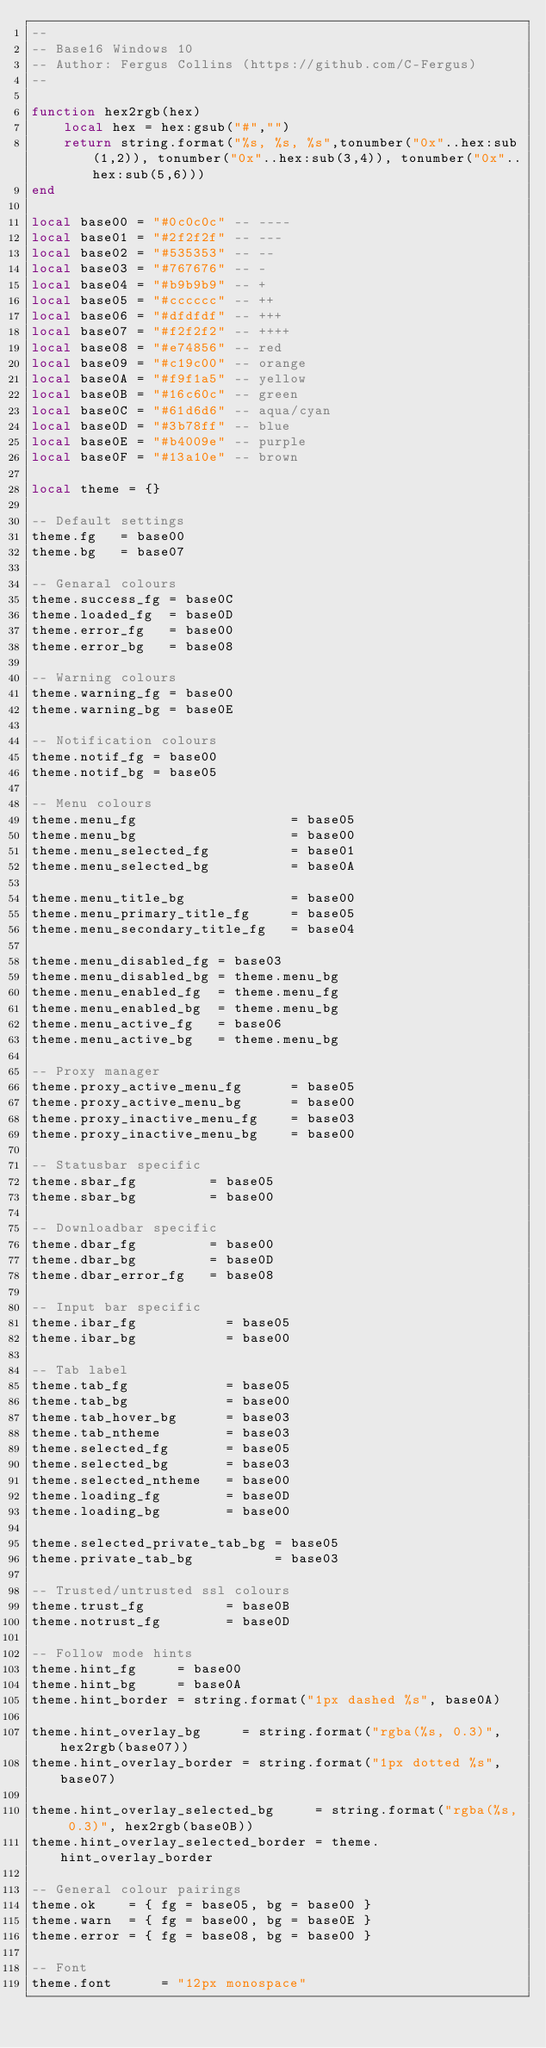<code> <loc_0><loc_0><loc_500><loc_500><_Lua_>--
-- Base16 Windows 10
-- Author: Fergus Collins (https://github.com/C-Fergus)
--

function hex2rgb(hex)
    local hex = hex:gsub("#","")
    return string.format("%s, %s, %s",tonumber("0x"..hex:sub(1,2)), tonumber("0x"..hex:sub(3,4)), tonumber("0x"..hex:sub(5,6)))
end

local base00 = "#0c0c0c" -- ----
local base01 = "#2f2f2f" -- ---
local base02 = "#535353" -- --
local base03 = "#767676" -- -
local base04 = "#b9b9b9" -- +
local base05 = "#cccccc" -- ++
local base06 = "#dfdfdf" -- +++
local base07 = "#f2f2f2" -- ++++
local base08 = "#e74856" -- red
local base09 = "#c19c00" -- orange
local base0A = "#f9f1a5" -- yellow
local base0B = "#16c60c" -- green
local base0C = "#61d6d6" -- aqua/cyan
local base0D = "#3b78ff" -- blue
local base0E = "#b4009e" -- purple
local base0F = "#13a10e" -- brown

local theme = {}

-- Default settings
theme.fg   = base00
theme.bg   = base07

-- Genaral colours
theme.success_fg = base0C
theme.loaded_fg  = base0D
theme.error_fg   = base00
theme.error_bg   = base08

-- Warning colours
theme.warning_fg = base00
theme.warning_bg = base0E

-- Notification colours
theme.notif_fg = base00
theme.notif_bg = base05

-- Menu colours
theme.menu_fg                   = base05
theme.menu_bg                   = base00
theme.menu_selected_fg          = base01
theme.menu_selected_bg          = base0A

theme.menu_title_bg             = base00
theme.menu_primary_title_fg     = base05
theme.menu_secondary_title_fg   = base04

theme.menu_disabled_fg = base03
theme.menu_disabled_bg = theme.menu_bg
theme.menu_enabled_fg  = theme.menu_fg
theme.menu_enabled_bg  = theme.menu_bg
theme.menu_active_fg   = base06
theme.menu_active_bg   = theme.menu_bg

-- Proxy manager
theme.proxy_active_menu_fg      = base05
theme.proxy_active_menu_bg      = base00
theme.proxy_inactive_menu_fg    = base03
theme.proxy_inactive_menu_bg    = base00

-- Statusbar specific
theme.sbar_fg         = base05
theme.sbar_bg         = base00

-- Downloadbar specific
theme.dbar_fg         = base00
theme.dbar_bg         = base0D
theme.dbar_error_fg   = base08

-- Input bar specific
theme.ibar_fg           = base05
theme.ibar_bg           = base00

-- Tab label
theme.tab_fg            = base05
theme.tab_bg            = base00
theme.tab_hover_bg      = base03
theme.tab_ntheme        = base03
theme.selected_fg       = base05
theme.selected_bg       = base03
theme.selected_ntheme   = base00
theme.loading_fg        = base0D
theme.loading_bg        = base00

theme.selected_private_tab_bg = base05
theme.private_tab_bg          = base03

-- Trusted/untrusted ssl colours
theme.trust_fg          = base0B
theme.notrust_fg        = base0D

-- Follow mode hints
theme.hint_fg     = base00
theme.hint_bg     = base0A
theme.hint_border = string.format("1px dashed %s", base0A)

theme.hint_overlay_bg     = string.format("rgba(%s, 0.3)", hex2rgb(base07))
theme.hint_overlay_border = string.format("1px dotted %s", base07)

theme.hint_overlay_selected_bg     = string.format("rgba(%s, 0.3)", hex2rgb(base0B))
theme.hint_overlay_selected_border = theme.hint_overlay_border

-- General colour pairings
theme.ok    = { fg = base05, bg = base00 }
theme.warn  = { fg = base00, bg = base0E }
theme.error = { fg = base08, bg = base00 }

-- Font
theme.font      = "12px monospace"</code> 